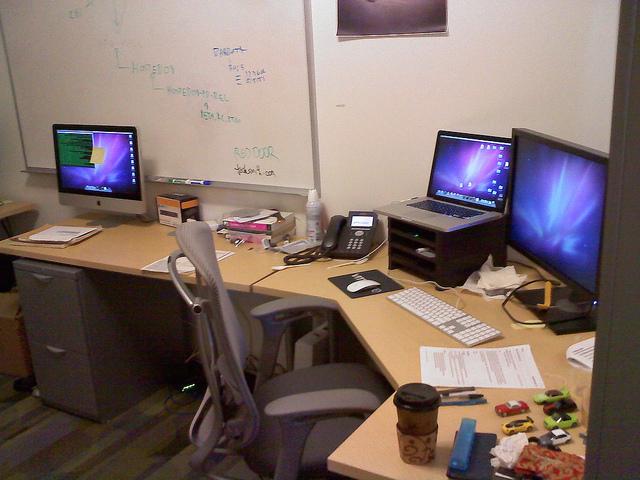What book is laying on the desk?
Keep it brief. Text. What vessel is holding the drinkable liquid?
Be succinct. Cup. How many computer screens are there?
Answer briefly. 3. How many drawers are there?
Answer briefly. 2. Is this an office desk?
Keep it brief. Yes. How many monitors are on the desk?
Short answer required. 3. How many laptops are there?
Answer briefly. 1. IS the desk messy?
Write a very short answer. No. How many screens do you see?
Short answer required. 3. Is this a single workstation?
Answer briefly. Yes. 